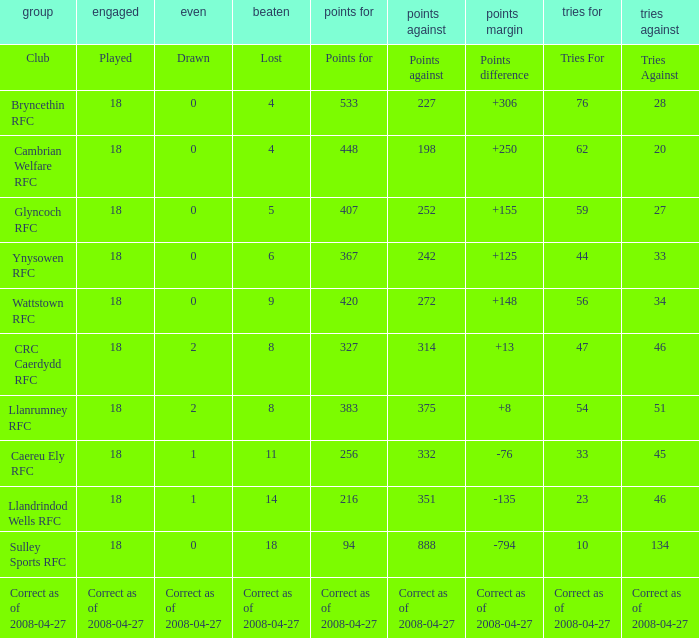Help me parse the entirety of this table. {'header': ['group', 'engaged', 'even', 'beaten', 'points for', 'points against', 'points margin', 'tries for', 'tries against'], 'rows': [['Club', 'Played', 'Drawn', 'Lost', 'Points for', 'Points against', 'Points difference', 'Tries For', 'Tries Against'], ['Bryncethin RFC', '18', '0', '4', '533', '227', '+306', '76', '28'], ['Cambrian Welfare RFC', '18', '0', '4', '448', '198', '+250', '62', '20'], ['Glyncoch RFC', '18', '0', '5', '407', '252', '+155', '59', '27'], ['Ynysowen RFC', '18', '0', '6', '367', '242', '+125', '44', '33'], ['Wattstown RFC', '18', '0', '9', '420', '272', '+148', '56', '34'], ['CRC Caerdydd RFC', '18', '2', '8', '327', '314', '+13', '47', '46'], ['Llanrumney RFC', '18', '2', '8', '383', '375', '+8', '54', '51'], ['Caereu Ely RFC', '18', '1', '11', '256', '332', '-76', '33', '45'], ['Llandrindod Wells RFC', '18', '1', '14', '216', '351', '-135', '23', '46'], ['Sulley Sports RFC', '18', '0', '18', '94', '888', '-794', '10', '134'], ['Correct as of 2008-04-27', 'Correct as of 2008-04-27', 'Correct as of 2008-04-27', 'Correct as of 2008-04-27', 'Correct as of 2008-04-27', 'Correct as of 2008-04-27', 'Correct as of 2008-04-27', 'Correct as of 2008-04-27', 'Correct as of 2008-04-27']]} What is the value of the item "Points" when the value of the item "Points against" is 272? 420.0. 